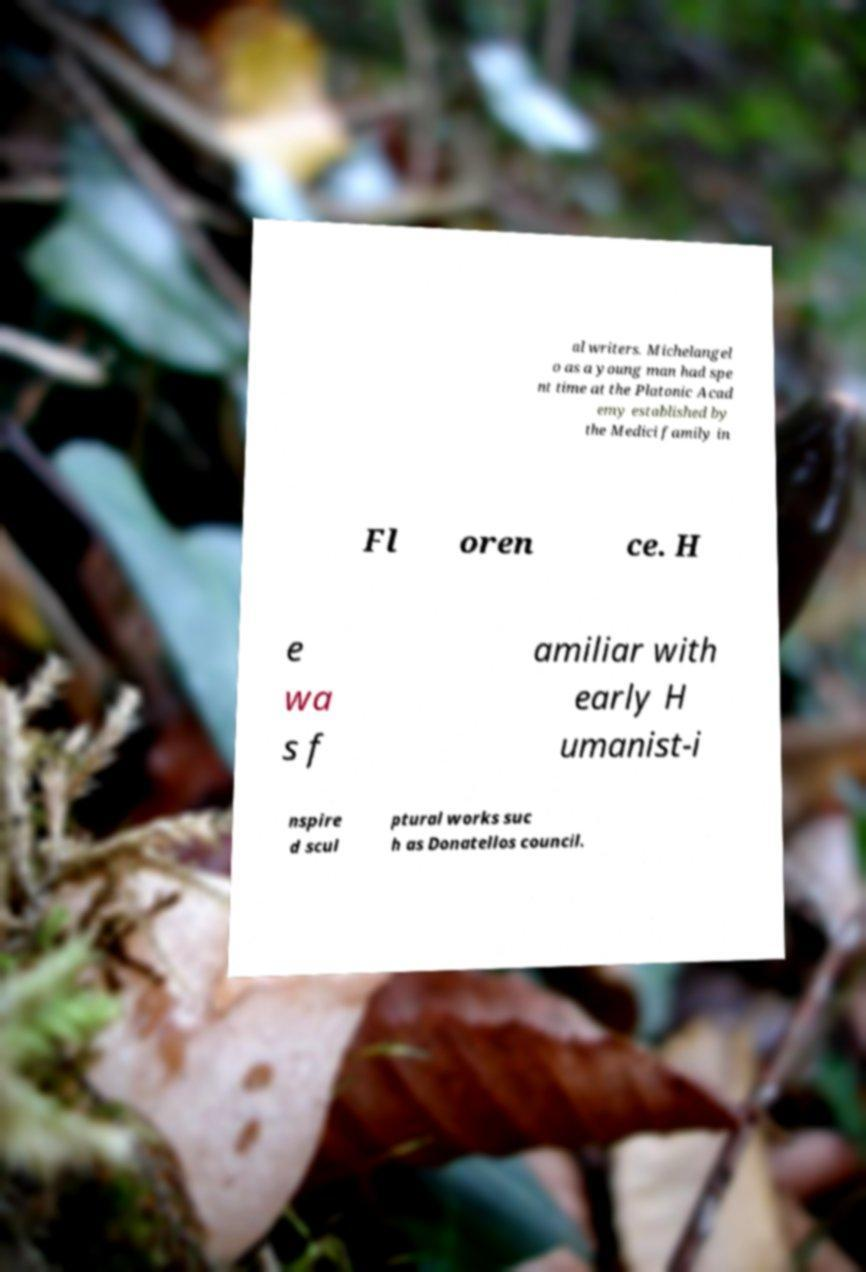There's text embedded in this image that I need extracted. Can you transcribe it verbatim? al writers. Michelangel o as a young man had spe nt time at the Platonic Acad emy established by the Medici family in Fl oren ce. H e wa s f amiliar with early H umanist-i nspire d scul ptural works suc h as Donatellos council. 